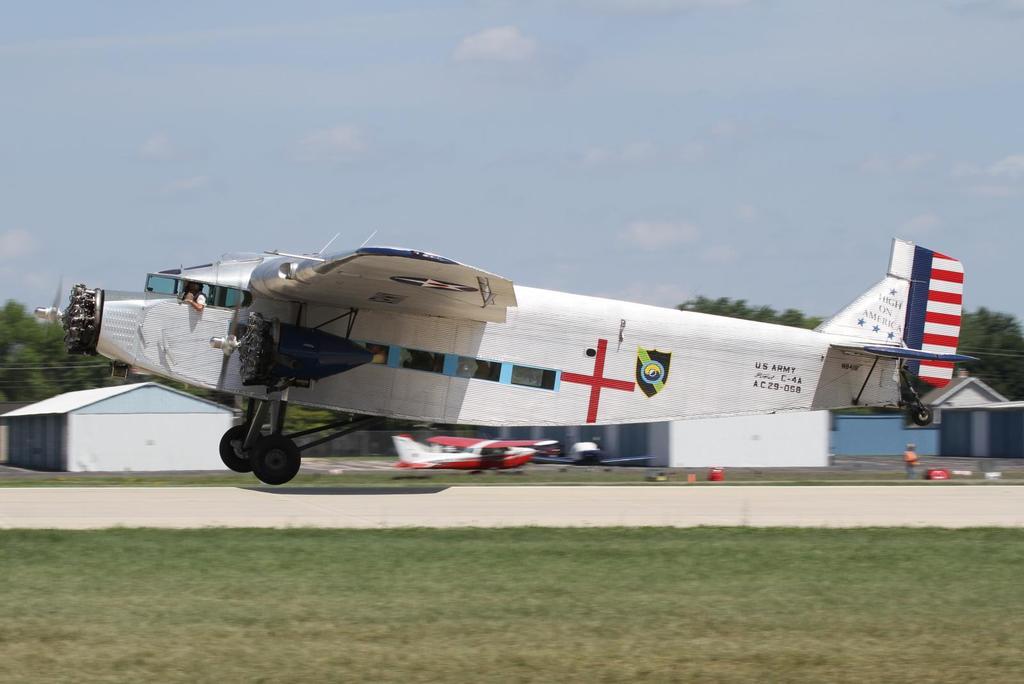What symbol is on the middle of the airplane?
Your answer should be compact. +. Who does this plane belong to?
Your answer should be very brief. Us army. 